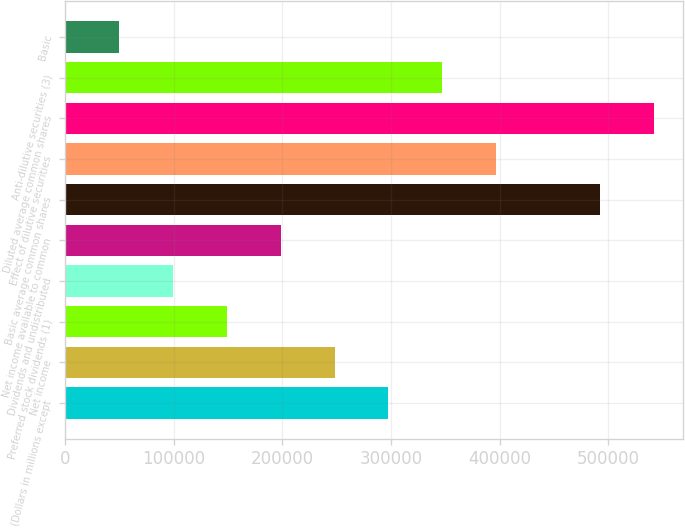Convert chart. <chart><loc_0><loc_0><loc_500><loc_500><bar_chart><fcel>(Dollars in millions except<fcel>Net income<fcel>Preferred stock dividends (1)<fcel>Dividends and undistributed<fcel>Net income available to common<fcel>Basic average common shares<fcel>Effect of dilutive securities<fcel>Diluted average common shares<fcel>Anti-dilutive securities (3)<fcel>Basic<nl><fcel>297645<fcel>248038<fcel>148824<fcel>99217.4<fcel>198431<fcel>492598<fcel>396858<fcel>542205<fcel>347252<fcel>49610.6<nl></chart> 